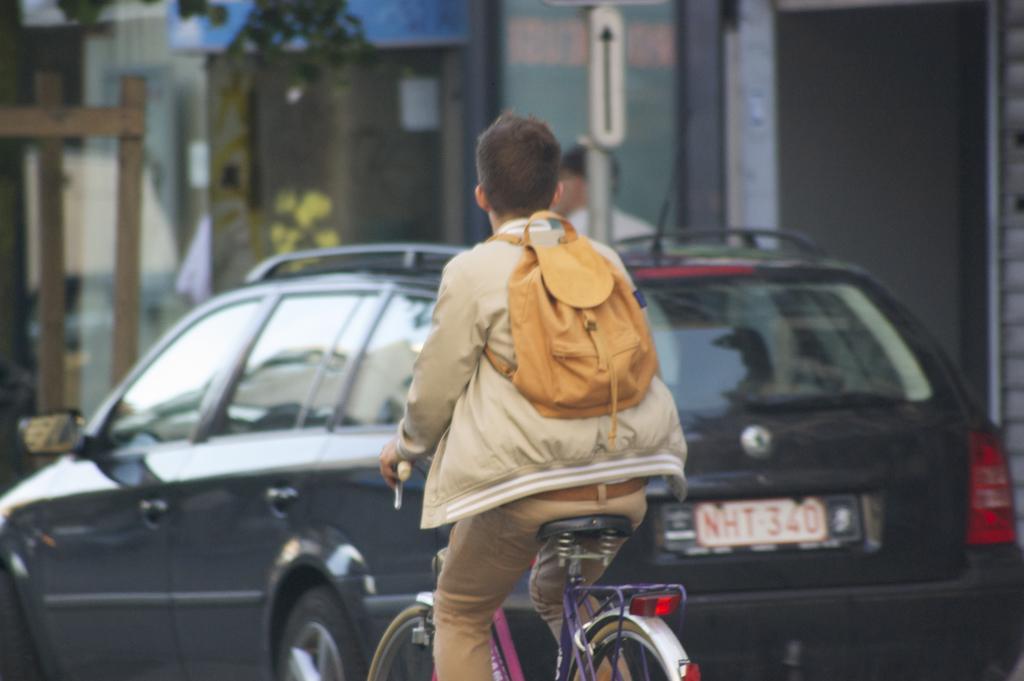Please provide a concise description of this image. In this picture a man is riding a bicycle. Backside of the man there is a black car and background of them there is a building. 